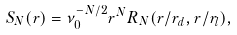Convert formula to latex. <formula><loc_0><loc_0><loc_500><loc_500>S _ { N } ( r ) = \nu _ { 0 } ^ { - N / 2 } r ^ { N } R _ { N } ( r / r _ { d } , r / r _ { l } ) ,</formula> 